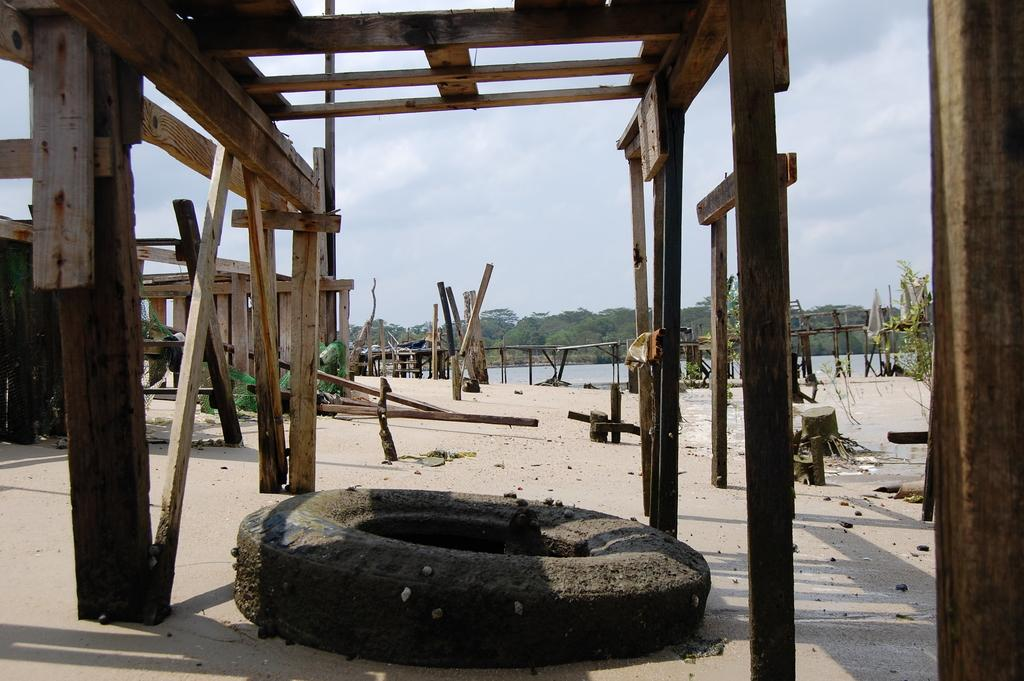What object can be seen on the path in the image? There is a tire on the path in the image. What type of structures are present in the image? There are wooden poles in the image. What natural element is visible in the image? There is water visible in the image. What type of vegetation is present in the image? There are trees in the image. How would you describe the weather in the image? The sky is cloudy in the image. What time of day is it in the image, and is the club open? The time of day cannot be determined from the image, and there is no club present in the image. Is the person in the image sleeping? There is no person visible in the image, so it cannot be determined if anyone is sleeping. 